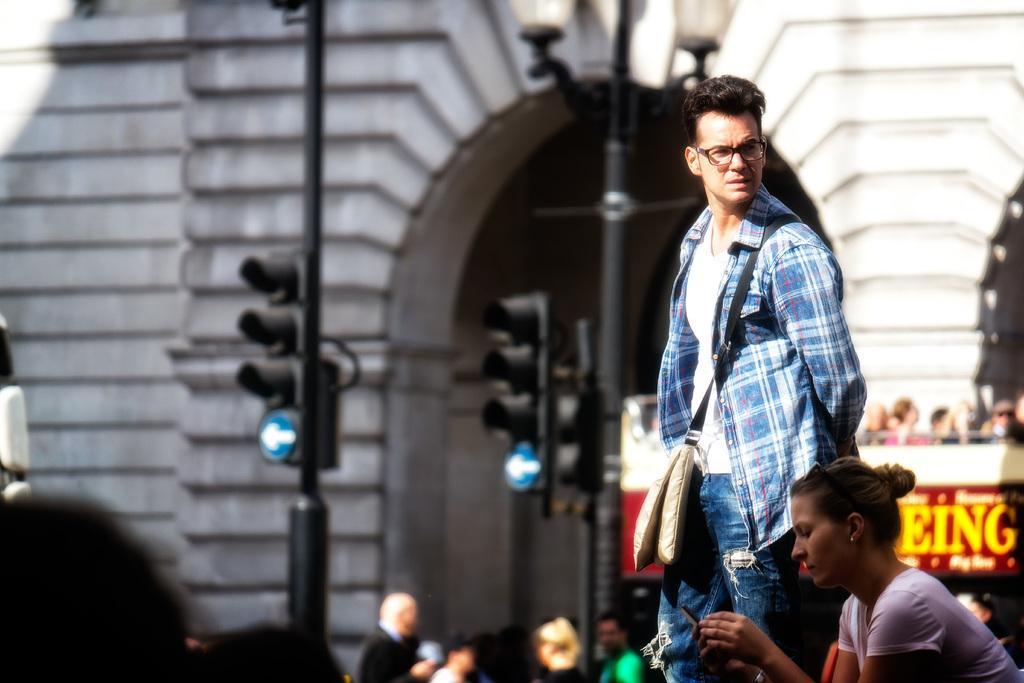Could you give a brief overview of what you see in this image? This is the man standing and a woman sitting and holding a mobile phone. I can see the traffic signals attached to the poles. I can see a light pole. This is a building with an arch. In the background, I can see groups of people. 